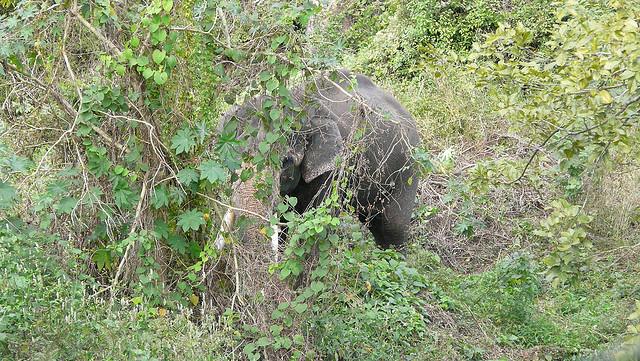What is the danger illustrated by this photo?
Give a very brief answer. Elephant. What type of animal is pictured?
Quick response, please. Elephant. What could live in this cave?
Be succinct. Bear. Does this animal look dangerous?
Write a very short answer. No. Do you think it would be wise to climb into this hole and explore it?
Give a very brief answer. No. 